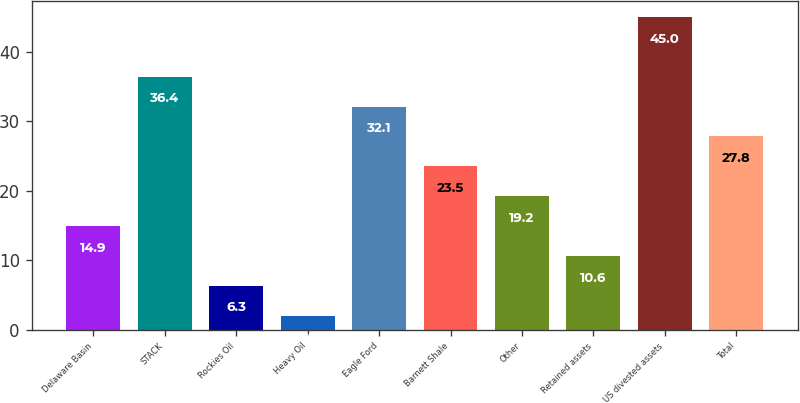<chart> <loc_0><loc_0><loc_500><loc_500><bar_chart><fcel>Delaware Basin<fcel>STACK<fcel>Rockies Oil<fcel>Heavy Oil<fcel>Eagle Ford<fcel>Barnett Shale<fcel>Other<fcel>Retained assets<fcel>US divested assets<fcel>Total<nl><fcel>14.9<fcel>36.4<fcel>6.3<fcel>2<fcel>32.1<fcel>23.5<fcel>19.2<fcel>10.6<fcel>45<fcel>27.8<nl></chart> 